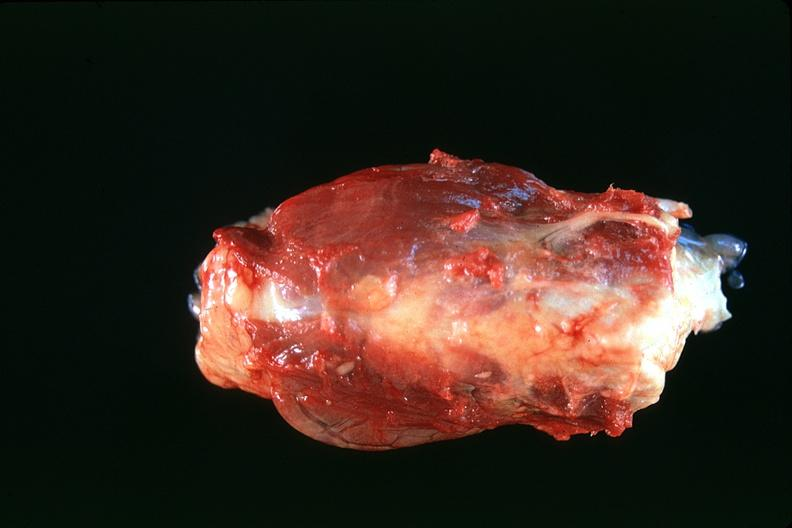does this image show thyroid, normal?
Answer the question using a single word or phrase. Yes 